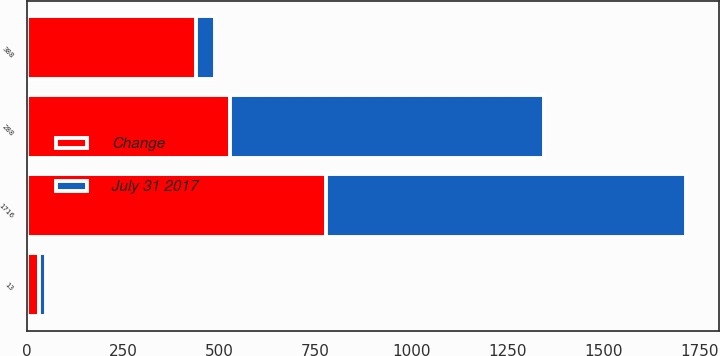Convert chart to OTSL. <chart><loc_0><loc_0><loc_500><loc_500><stacked_bar_chart><ecel><fcel>1716<fcel>13<fcel>388<fcel>288<nl><fcel>Change<fcel>777<fcel>31<fcel>438<fcel>529<nl><fcel>July 31 2017<fcel>939<fcel>18<fcel>50<fcel>817<nl></chart> 